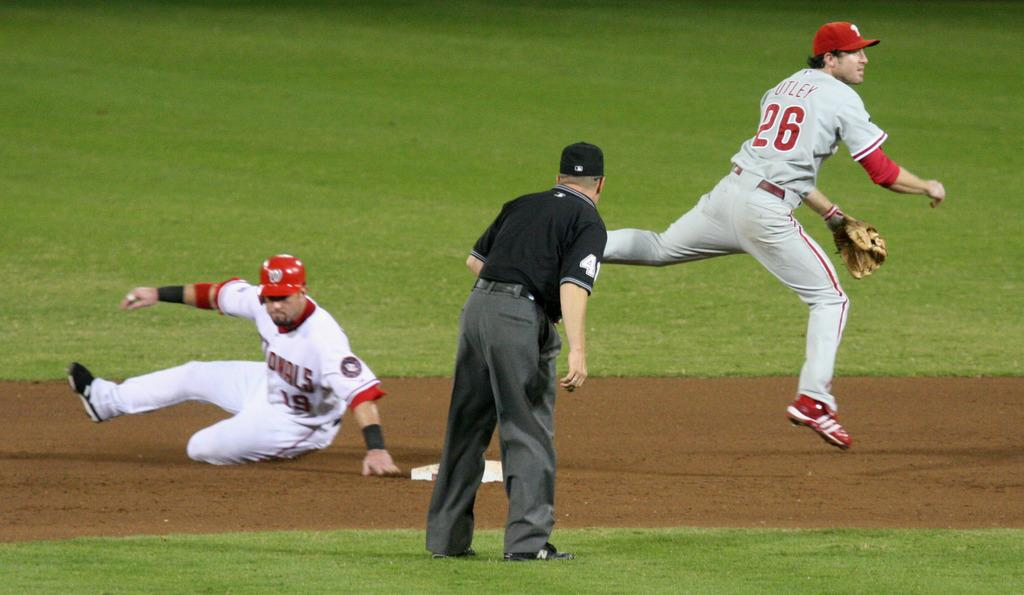<image>
Summarize the visual content of the image. A Nationals player slid into base and the baseball player number 26 is turned away. 